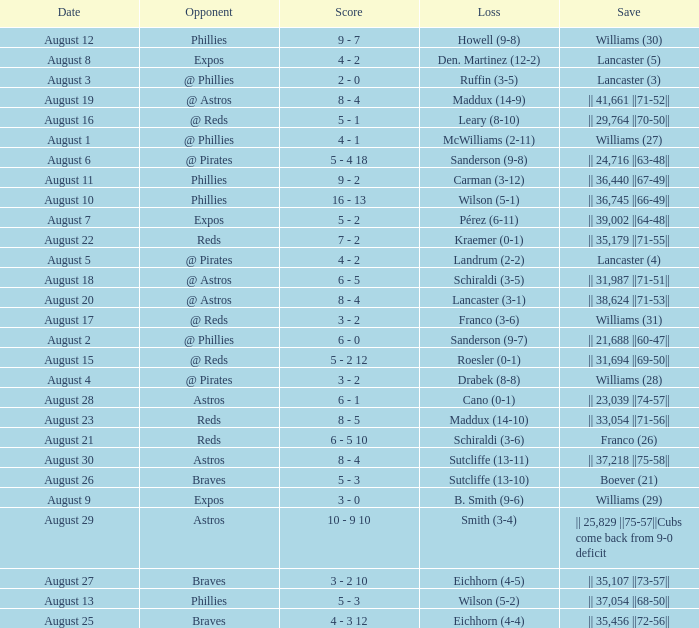Name the score for save of lancaster (3) 2 - 0. 